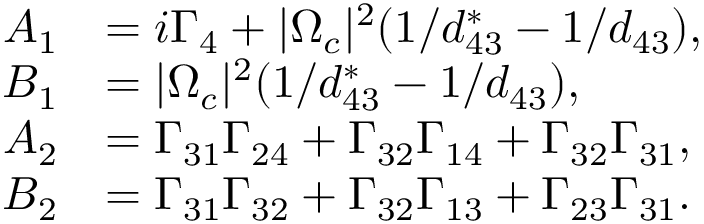<formula> <loc_0><loc_0><loc_500><loc_500>\begin{array} { r l } { A _ { 1 } } & { = i \Gamma _ { 4 } + | \Omega _ { c } | ^ { 2 } ( 1 / d _ { 4 3 } ^ { \ast } - 1 / d _ { 4 3 } ) , } \\ { B _ { 1 } } & { = | \Omega _ { c } | ^ { 2 } ( 1 / d _ { 4 3 } ^ { \ast } - 1 / d _ { 4 3 } ) , } \\ { A _ { 2 } } & { = \Gamma _ { 3 1 } \Gamma _ { 2 4 } + \Gamma _ { 3 2 } \Gamma _ { 1 4 } + \Gamma _ { 3 2 } \Gamma _ { 3 1 } , } \\ { B _ { 2 } } & { = \Gamma _ { 3 1 } \Gamma _ { 3 2 } + \Gamma _ { 3 2 } \Gamma _ { 1 3 } + \Gamma _ { 2 3 } \Gamma _ { 3 1 } . } \end{array}</formula> 